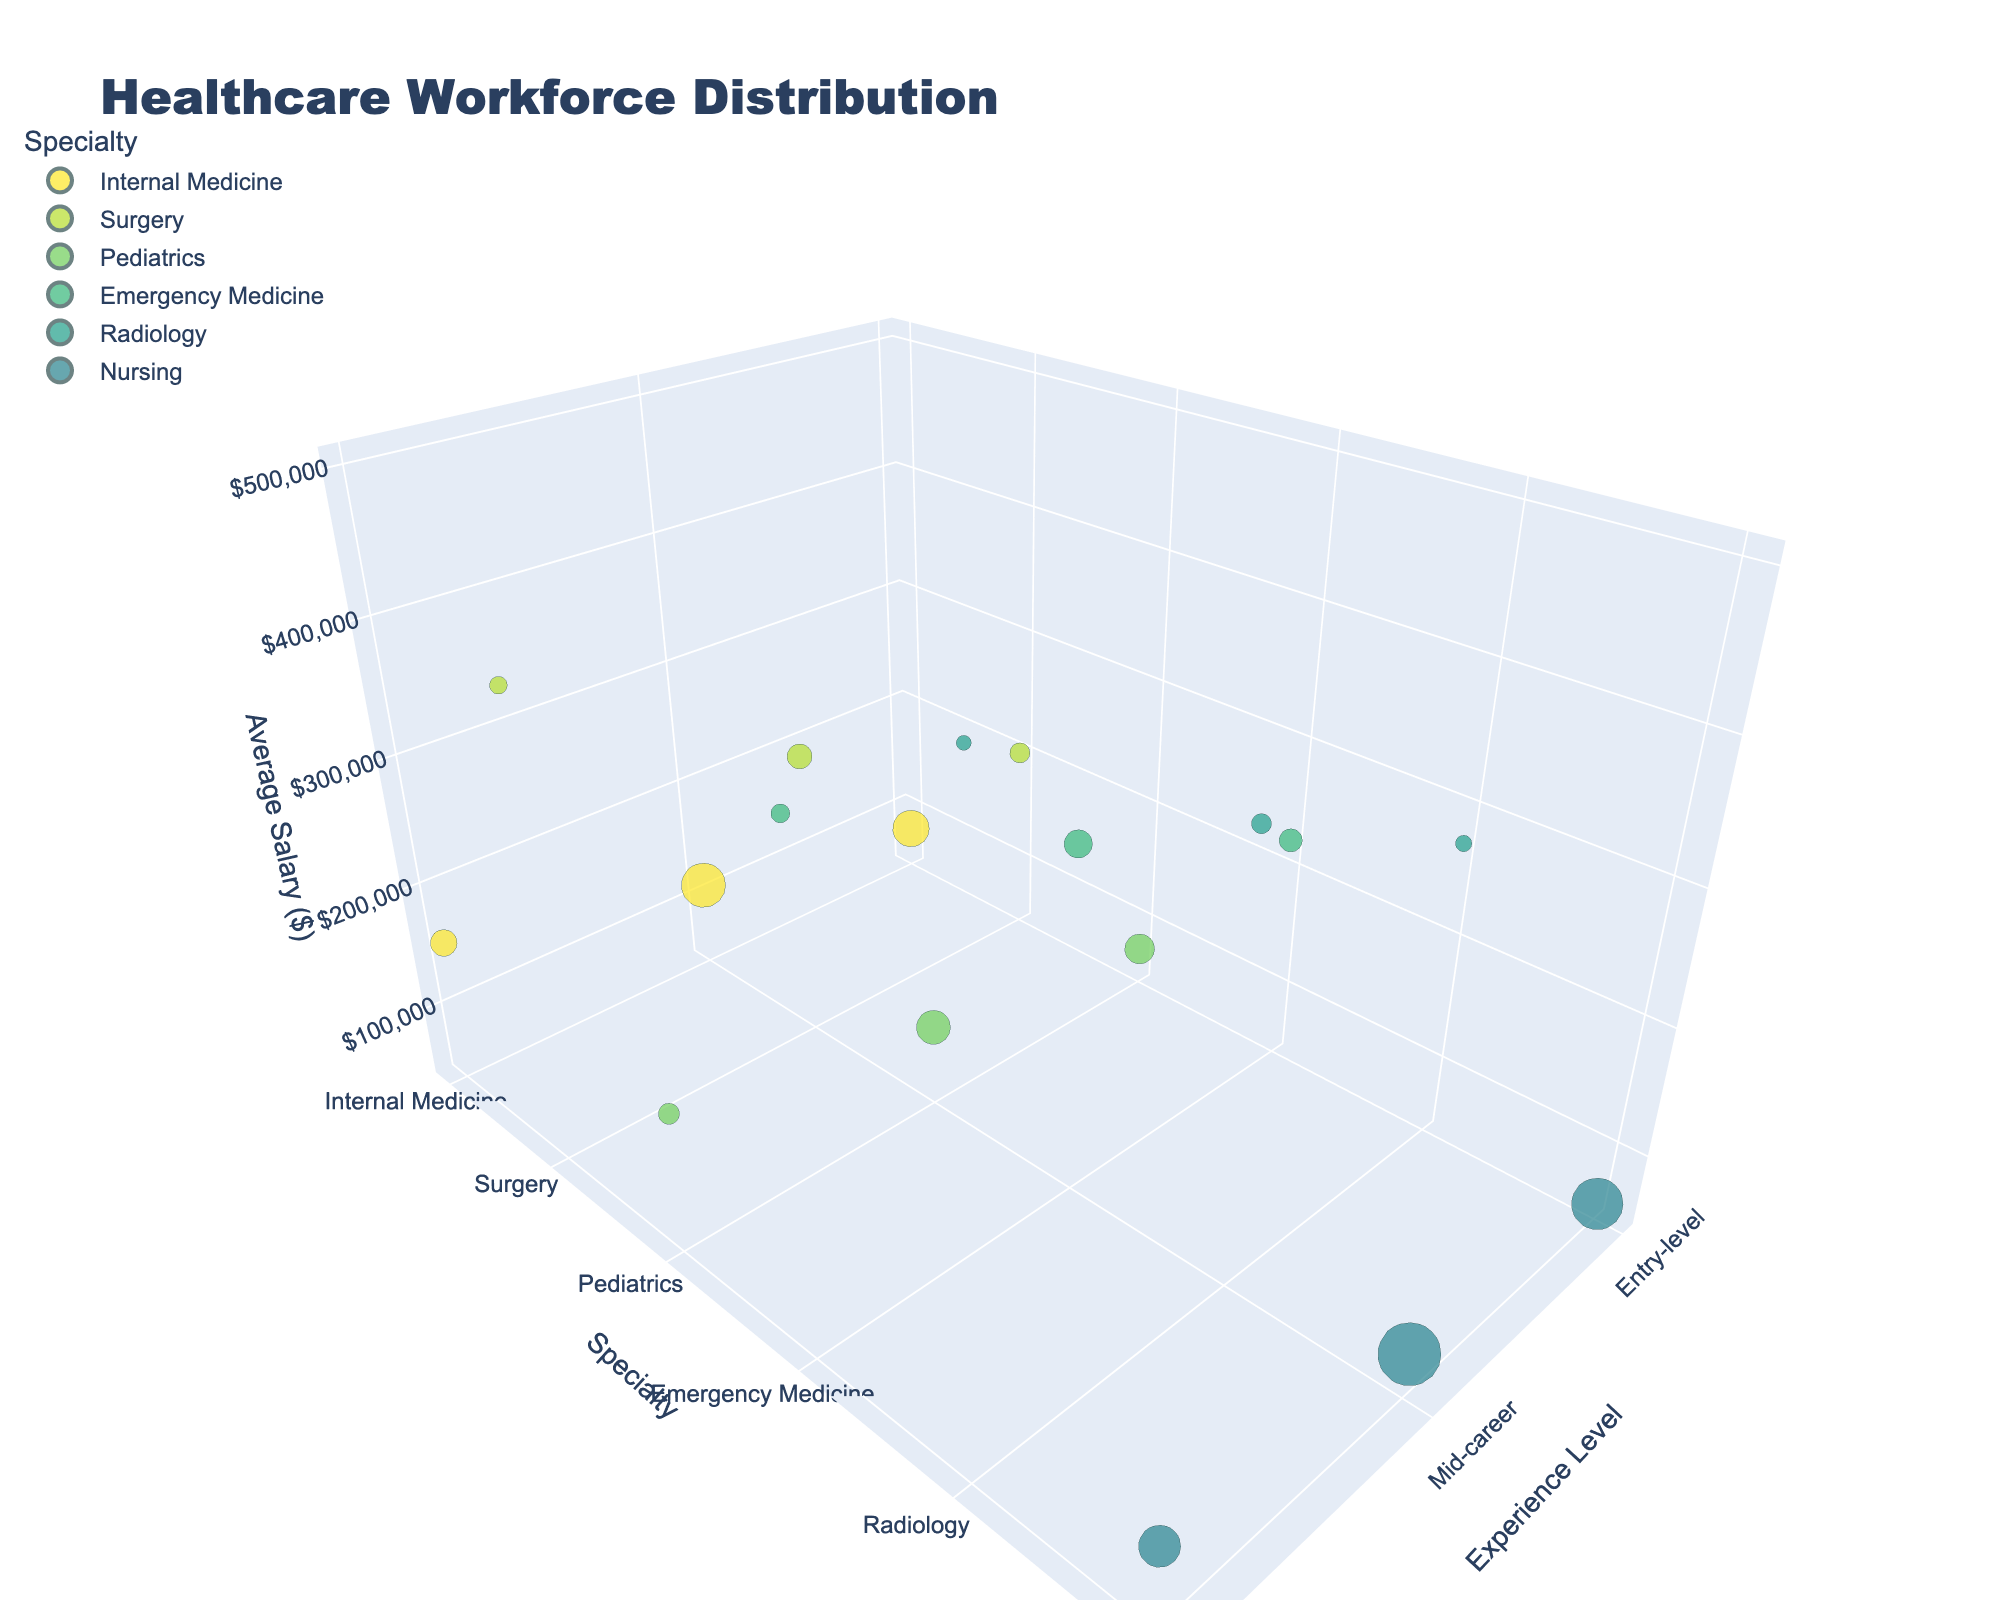How many specialties are represented in the chart? Count the different categories in the "Specialty" axis.
Answer: 6 Which experience level has the highest average salary in Radiology? Look along the "Radiology" category in the "Specialty" axis and compare the positions on the "Average Salary" axis among all experience levels.
Answer: Senior What is the average salary range for senior staff in Emergency Medicine? Locate the "Senior" experience level on the "Experience Level" axis, find the bubble for "Emergency Medicine" on the "Specialty" axis, and check the "Salary Range" in the hover data.
Answer: $380,000 - $450,000 Which specialty has the largest number of entry-level staff? Look at the size of the bubbles along the "Entry-level" category in the "Experience Level" axis and find the largest bubble.
Answer: Nursing How does the average salary for mid-career Pediatrics compare to mid-career Internal Medicine? Find the "Mid-career" bubbles for both "Pediatrics" and "Internal Medicine" on the "Specialty" axis, then compare their positions on the "Average Salary" axis.
Answer: Pediatrics is lower What is the total number of staff in Surgery? Sum the "Number of Staff" for all experience levels (Entry-level, Mid-career, Senior) in "Surgery".
Answer: 150 Which specialty has the smallest average salary in entry-level? Compare the positions on the "Average Salary" axis for all bubbles in the "Entry-level" category on the "Experience Level" axis.
Answer: Nursing What is the difference in average salary between senior Internal Medicine and senior Radiology staff? Find the positions on the "Average Salary" axis for "Senior" level in both "Internal Medicine" and "Radiology", and calculate the difference between them.
Answer: $270,000 Are there more mid-career staff in Pediatrics or in Emergency Medicine? Compare the bubble sizes for "Mid-career" level in both "Pediatrics" and "Emergency Medicine" on the "Specialty" axis.
Answer: Pediatrics 